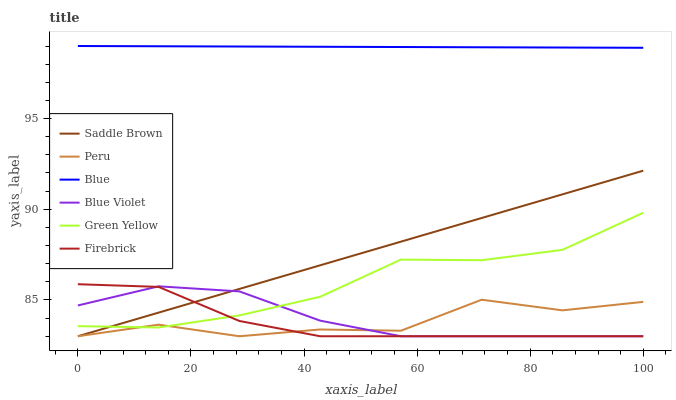Does Firebrick have the minimum area under the curve?
Answer yes or no. Yes. Does Blue have the maximum area under the curve?
Answer yes or no. Yes. Does Peru have the minimum area under the curve?
Answer yes or no. No. Does Peru have the maximum area under the curve?
Answer yes or no. No. Is Blue the smoothest?
Answer yes or no. Yes. Is Peru the roughest?
Answer yes or no. Yes. Is Firebrick the smoothest?
Answer yes or no. No. Is Firebrick the roughest?
Answer yes or no. No. Does Firebrick have the lowest value?
Answer yes or no. Yes. Does Green Yellow have the lowest value?
Answer yes or no. No. Does Blue have the highest value?
Answer yes or no. Yes. Does Firebrick have the highest value?
Answer yes or no. No. Is Peru less than Blue?
Answer yes or no. Yes. Is Blue greater than Firebrick?
Answer yes or no. Yes. Does Blue Violet intersect Peru?
Answer yes or no. Yes. Is Blue Violet less than Peru?
Answer yes or no. No. Is Blue Violet greater than Peru?
Answer yes or no. No. Does Peru intersect Blue?
Answer yes or no. No. 